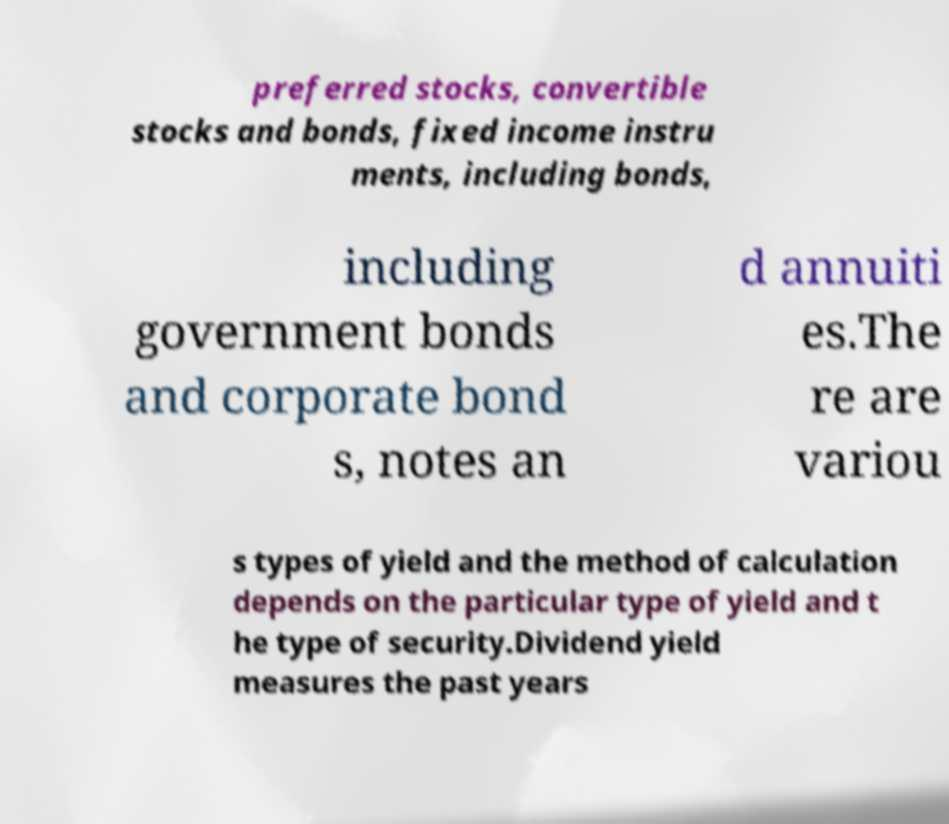Can you read and provide the text displayed in the image?This photo seems to have some interesting text. Can you extract and type it out for me? preferred stocks, convertible stocks and bonds, fixed income instru ments, including bonds, including government bonds and corporate bond s, notes an d annuiti es.The re are variou s types of yield and the method of calculation depends on the particular type of yield and t he type of security.Dividend yield measures the past years 